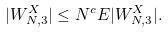<formula> <loc_0><loc_0><loc_500><loc_500>| W _ { N , 3 } ^ { X } | \leq N ^ { c } E | W _ { N , 3 } ^ { X } | .</formula> 